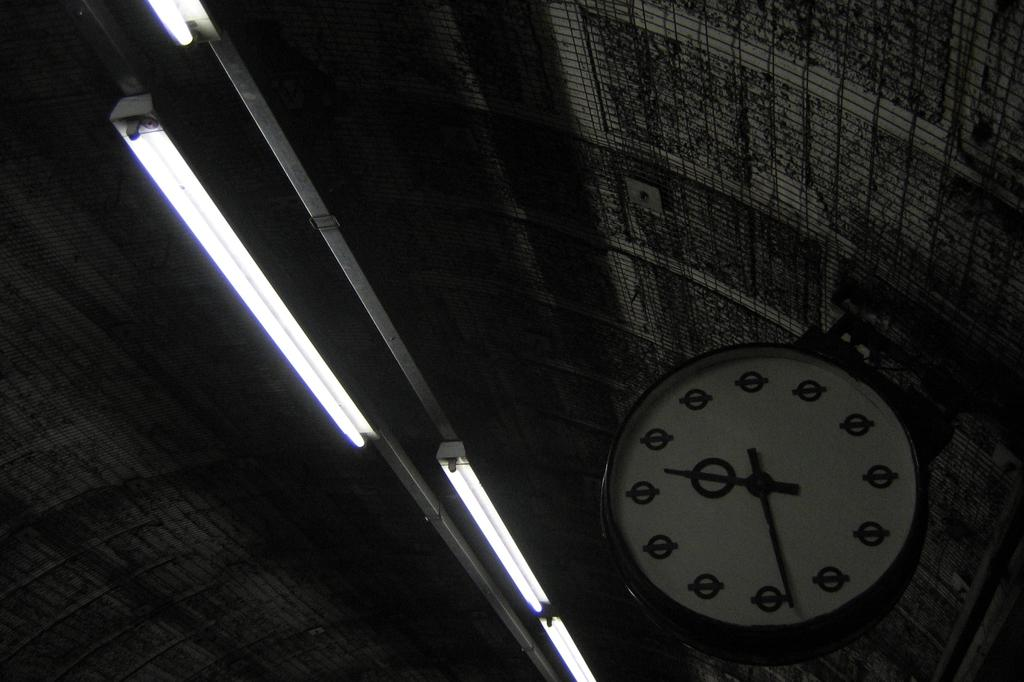What object is attached to the wall in the image? There is a clock attached to the wall in the image. What type of lighting is present in the image? There are lights attached to the ceiling in the image. What color scheme is used in the image? The image appears to be in black and white. Can you see a stick being used to stir a kettle in the image? There is no stick or kettle present in the image. Is there any wax visible on the floor in the image? There is no wax visible on the floor in the image. 